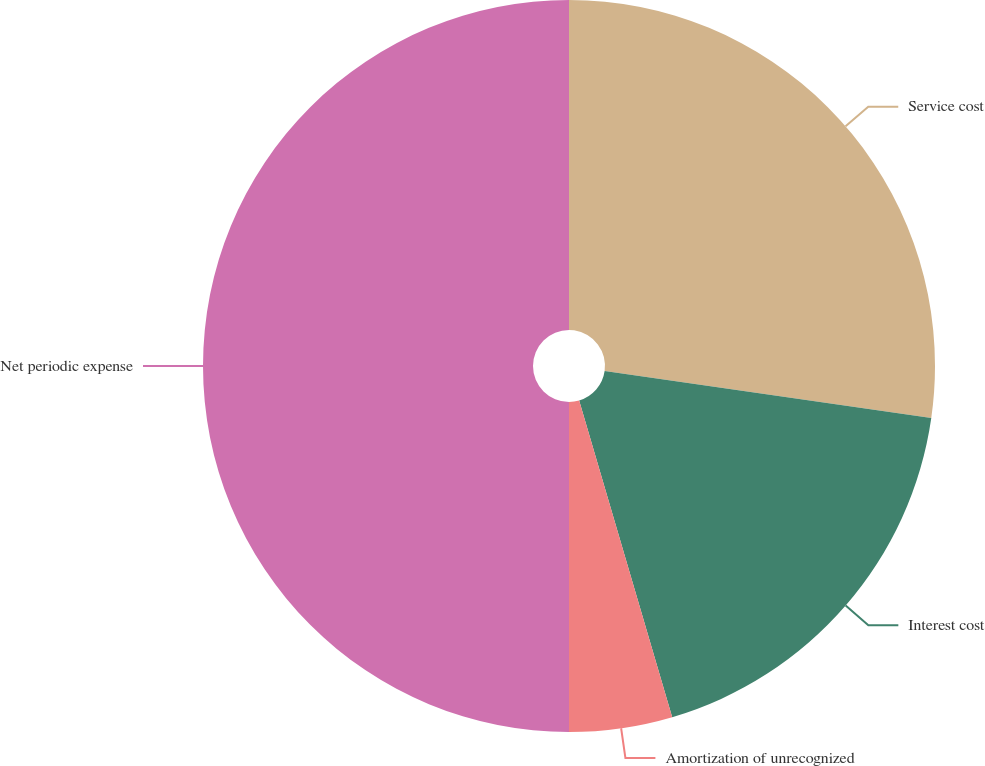Convert chart. <chart><loc_0><loc_0><loc_500><loc_500><pie_chart><fcel>Service cost<fcel>Interest cost<fcel>Amortization of unrecognized<fcel>Net periodic expense<nl><fcel>27.27%<fcel>18.18%<fcel>4.55%<fcel>50.0%<nl></chart> 